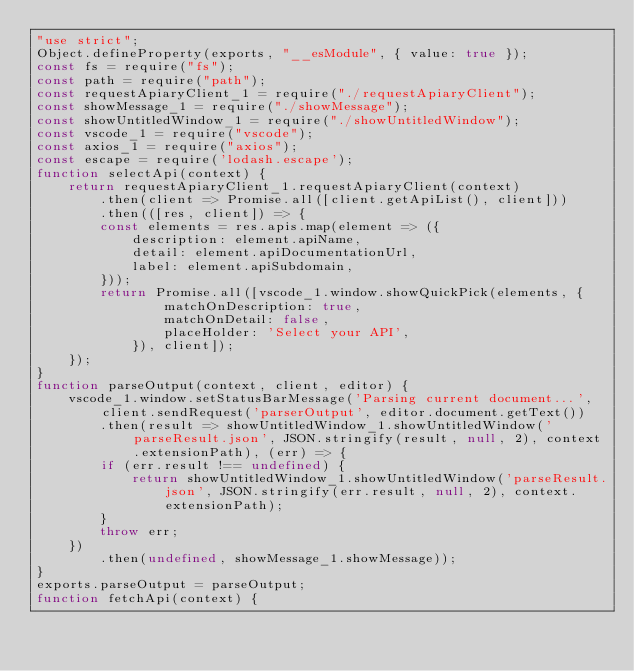<code> <loc_0><loc_0><loc_500><loc_500><_JavaScript_>"use strict";
Object.defineProperty(exports, "__esModule", { value: true });
const fs = require("fs");
const path = require("path");
const requestApiaryClient_1 = require("./requestApiaryClient");
const showMessage_1 = require("./showMessage");
const showUntitledWindow_1 = require("./showUntitledWindow");
const vscode_1 = require("vscode");
const axios_1 = require("axios");
const escape = require('lodash.escape');
function selectApi(context) {
    return requestApiaryClient_1.requestApiaryClient(context)
        .then(client => Promise.all([client.getApiList(), client]))
        .then(([res, client]) => {
        const elements = res.apis.map(element => ({
            description: element.apiName,
            detail: element.apiDocumentationUrl,
            label: element.apiSubdomain,
        }));
        return Promise.all([vscode_1.window.showQuickPick(elements, {
                matchOnDescription: true,
                matchOnDetail: false,
                placeHolder: 'Select your API',
            }), client]);
    });
}
function parseOutput(context, client, editor) {
    vscode_1.window.setStatusBarMessage('Parsing current document...', client.sendRequest('parserOutput', editor.document.getText())
        .then(result => showUntitledWindow_1.showUntitledWindow('parseResult.json', JSON.stringify(result, null, 2), context.extensionPath), (err) => {
        if (err.result !== undefined) {
            return showUntitledWindow_1.showUntitledWindow('parseResult.json', JSON.stringify(err.result, null, 2), context.extensionPath);
        }
        throw err;
    })
        .then(undefined, showMessage_1.showMessage));
}
exports.parseOutput = parseOutput;
function fetchApi(context) {</code> 